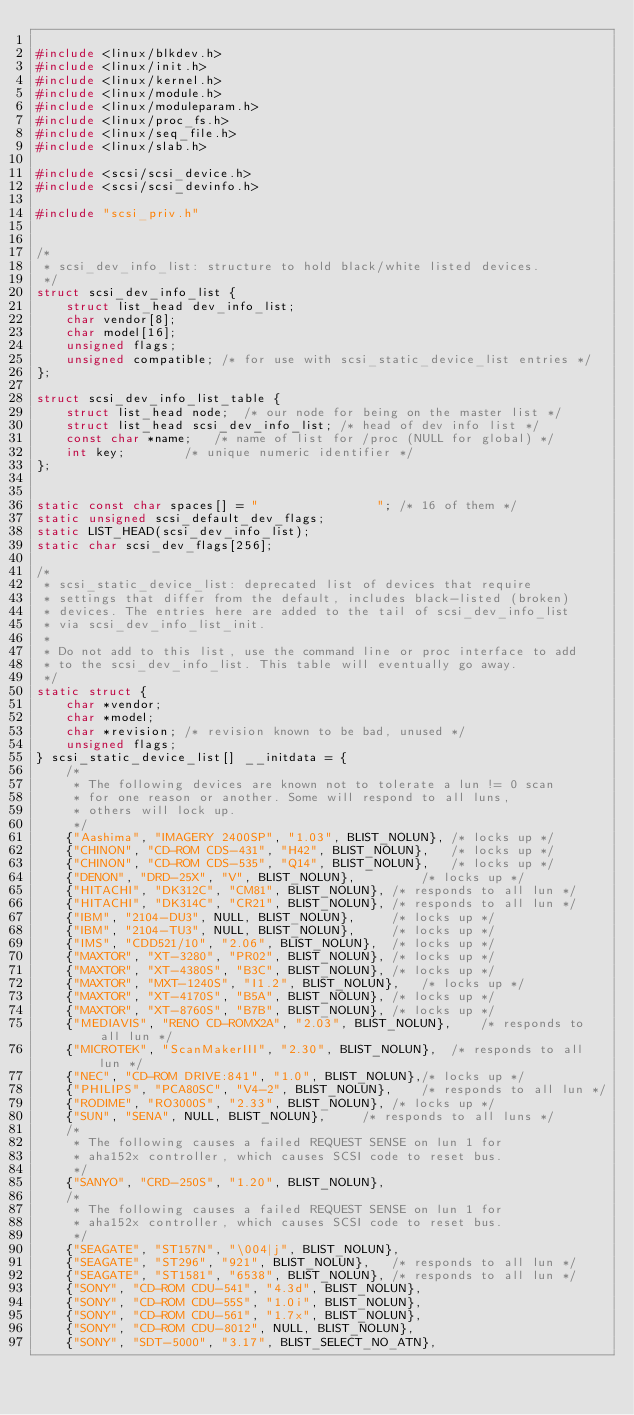Convert code to text. <code><loc_0><loc_0><loc_500><loc_500><_C_>
#include <linux/blkdev.h>
#include <linux/init.h>
#include <linux/kernel.h>
#include <linux/module.h>
#include <linux/moduleparam.h>
#include <linux/proc_fs.h>
#include <linux/seq_file.h>
#include <linux/slab.h>

#include <scsi/scsi_device.h>
#include <scsi/scsi_devinfo.h>

#include "scsi_priv.h"


/*
 * scsi_dev_info_list: structure to hold black/white listed devices.
 */
struct scsi_dev_info_list {
	struct list_head dev_info_list;
	char vendor[8];
	char model[16];
	unsigned flags;
	unsigned compatible; /* for use with scsi_static_device_list entries */
};

struct scsi_dev_info_list_table {
	struct list_head node;	/* our node for being on the master list */
	struct list_head scsi_dev_info_list; /* head of dev info list */
	const char *name;	/* name of list for /proc (NULL for global) */
	int key;		/* unique numeric identifier */
};


static const char spaces[] = "                "; /* 16 of them */
static unsigned scsi_default_dev_flags;
static LIST_HEAD(scsi_dev_info_list);
static char scsi_dev_flags[256];

/*
 * scsi_static_device_list: deprecated list of devices that require
 * settings that differ from the default, includes black-listed (broken)
 * devices. The entries here are added to the tail of scsi_dev_info_list
 * via scsi_dev_info_list_init.
 *
 * Do not add to this list, use the command line or proc interface to add
 * to the scsi_dev_info_list. This table will eventually go away.
 */
static struct {
	char *vendor;
	char *model;
	char *revision;	/* revision known to be bad, unused */
	unsigned flags;
} scsi_static_device_list[] __initdata = {
	/*
	 * The following devices are known not to tolerate a lun != 0 scan
	 * for one reason or another. Some will respond to all luns,
	 * others will lock up.
	 */
	{"Aashima", "IMAGERY 2400SP", "1.03", BLIST_NOLUN},	/* locks up */
	{"CHINON", "CD-ROM CDS-431", "H42", BLIST_NOLUN},	/* locks up */
	{"CHINON", "CD-ROM CDS-535", "Q14", BLIST_NOLUN},	/* locks up */
	{"DENON", "DRD-25X", "V", BLIST_NOLUN},			/* locks up */
	{"HITACHI", "DK312C", "CM81", BLIST_NOLUN},	/* responds to all lun */
	{"HITACHI", "DK314C", "CR21", BLIST_NOLUN},	/* responds to all lun */
	{"IBM", "2104-DU3", NULL, BLIST_NOLUN},		/* locks up */
	{"IBM", "2104-TU3", NULL, BLIST_NOLUN},		/* locks up */
	{"IMS", "CDD521/10", "2.06", BLIST_NOLUN},	/* locks up */
	{"MAXTOR", "XT-3280", "PR02", BLIST_NOLUN},	/* locks up */
	{"MAXTOR", "XT-4380S", "B3C", BLIST_NOLUN},	/* locks up */
	{"MAXTOR", "MXT-1240S", "I1.2", BLIST_NOLUN},	/* locks up */
	{"MAXTOR", "XT-4170S", "B5A", BLIST_NOLUN},	/* locks up */
	{"MAXTOR", "XT-8760S", "B7B", BLIST_NOLUN},	/* locks up */
	{"MEDIAVIS", "RENO CD-ROMX2A", "2.03", BLIST_NOLUN},	/* responds to all lun */
	{"MICROTEK", "ScanMakerIII", "2.30", BLIST_NOLUN},	/* responds to all lun */
	{"NEC", "CD-ROM DRIVE:841", "1.0", BLIST_NOLUN},/* locks up */
	{"PHILIPS", "PCA80SC", "V4-2", BLIST_NOLUN},	/* responds to all lun */
	{"RODIME", "RO3000S", "2.33", BLIST_NOLUN},	/* locks up */
	{"SUN", "SENA", NULL, BLIST_NOLUN},		/* responds to all luns */
	/*
	 * The following causes a failed REQUEST SENSE on lun 1 for
	 * aha152x controller, which causes SCSI code to reset bus.
	 */
	{"SANYO", "CRD-250S", "1.20", BLIST_NOLUN},
	/*
	 * The following causes a failed REQUEST SENSE on lun 1 for
	 * aha152x controller, which causes SCSI code to reset bus.
	 */
	{"SEAGATE", "ST157N", "\004|j", BLIST_NOLUN},
	{"SEAGATE", "ST296", "921", BLIST_NOLUN},	/* responds to all lun */
	{"SEAGATE", "ST1581", "6538", BLIST_NOLUN},	/* responds to all lun */
	{"SONY", "CD-ROM CDU-541", "4.3d", BLIST_NOLUN},
	{"SONY", "CD-ROM CDU-55S", "1.0i", BLIST_NOLUN},
	{"SONY", "CD-ROM CDU-561", "1.7x", BLIST_NOLUN},
	{"SONY", "CD-ROM CDU-8012", NULL, BLIST_NOLUN},
	{"SONY", "SDT-5000", "3.17", BLIST_SELECT_NO_ATN},</code> 